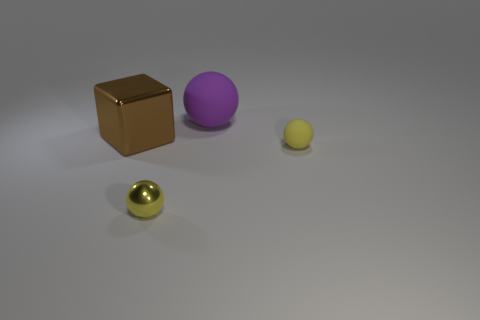Add 3 matte things. How many objects exist? 7 Subtract all cubes. How many objects are left? 3 Subtract all purple rubber things. Subtract all small red matte spheres. How many objects are left? 3 Add 3 large metallic things. How many large metallic things are left? 4 Add 1 purple objects. How many purple objects exist? 2 Subtract 0 green balls. How many objects are left? 4 